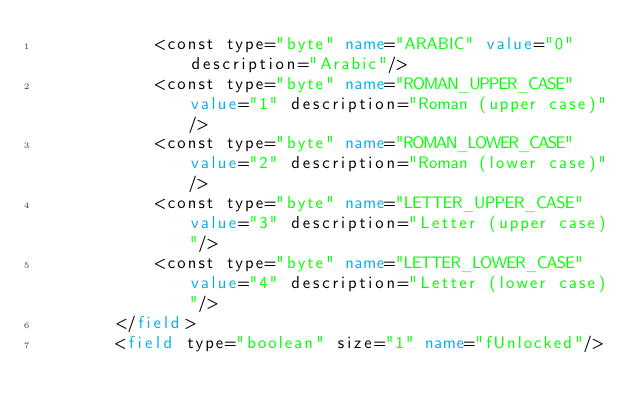<code> <loc_0><loc_0><loc_500><loc_500><_XML_>            <const type="byte" name="ARABIC" value="0" description="Arabic"/>
            <const type="byte" name="ROMAN_UPPER_CASE" value="1" description="Roman (upper case)"/>
            <const type="byte" name="ROMAN_LOWER_CASE" value="2" description="Roman (lower case)"/>
            <const type="byte" name="LETTER_UPPER_CASE" value="3" description="Letter (upper case)"/>
            <const type="byte" name="LETTER_LOWER_CASE" value="4" description="Letter (lower case)"/>
        </field>
        <field type="boolean" size="1" name="fUnlocked"/></code> 